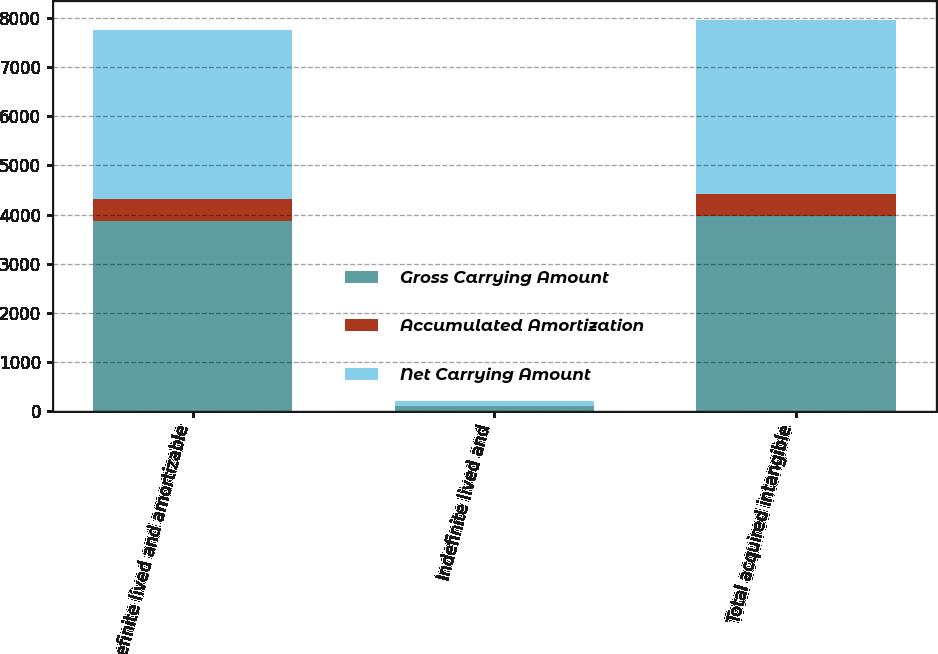Convert chart. <chart><loc_0><loc_0><loc_500><loc_500><stacked_bar_chart><ecel><fcel>Definite lived and amortizable<fcel>Indefinite lived and<fcel>Total acquired intangible<nl><fcel>Gross Carrying Amount<fcel>3873<fcel>100<fcel>3973<nl><fcel>Accumulated Amortization<fcel>437<fcel>0<fcel>437<nl><fcel>Net Carrying Amount<fcel>3436<fcel>100<fcel>3536<nl></chart> 